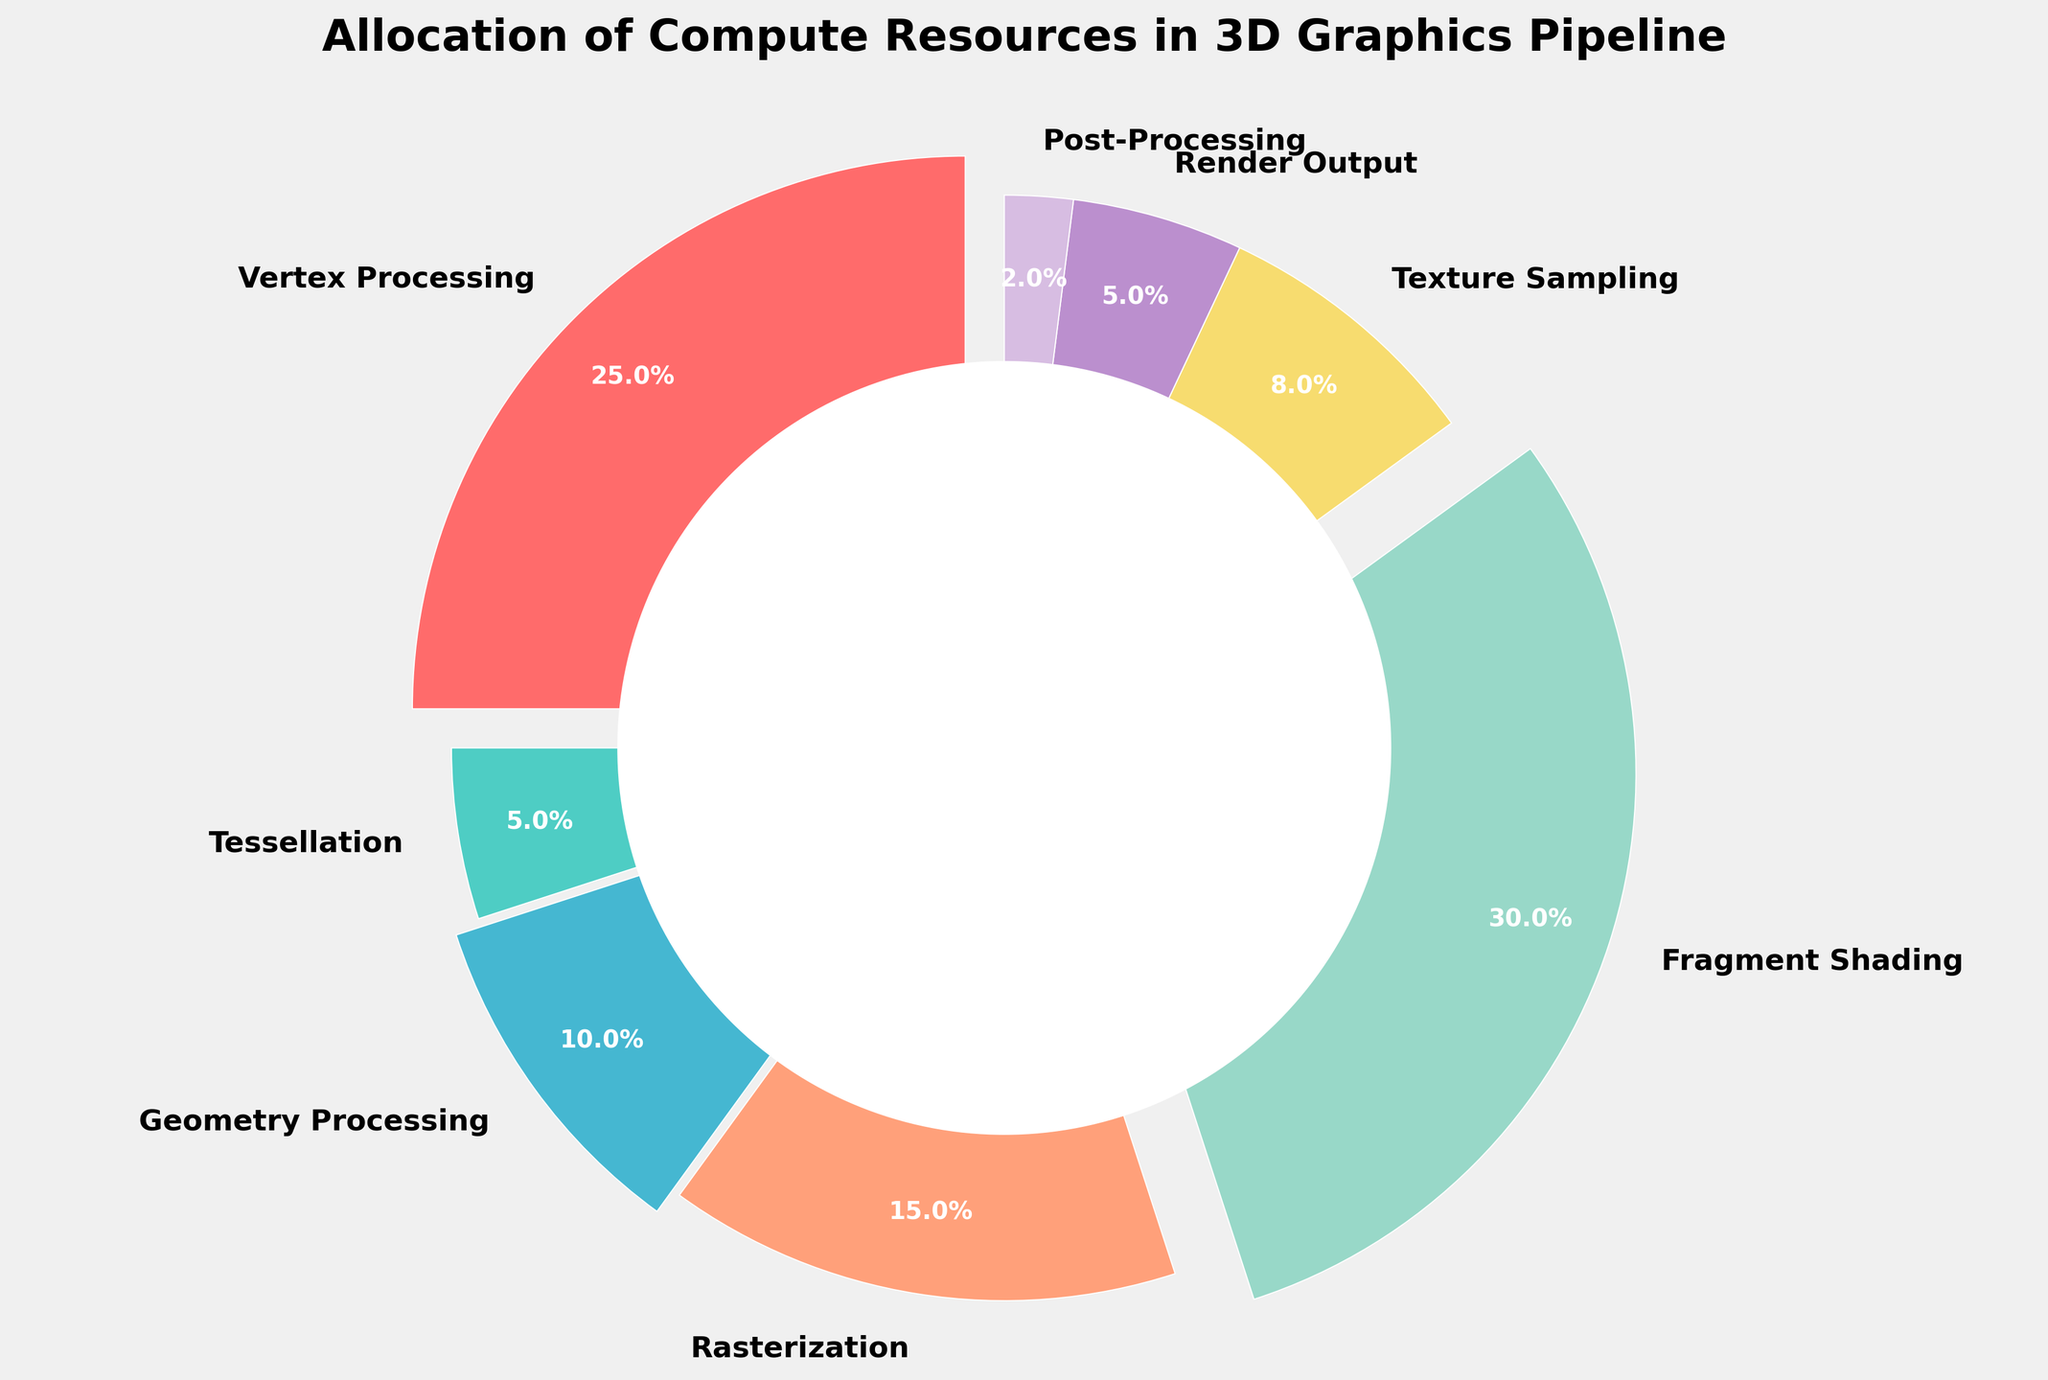What stage has the highest allocation of compute resources? By looking at the pie chart, the largest slice can be identified by its size and the percentage label. Fragment Shading has the highest allocation with 30%.
Answer: Fragment Shading Which two stages together contribute the smallest percentage of compute resources? Summing the smallest percentages labeled on the pie chart and finding the two stages that minimize this sum: Post-Processing (2%) and Render Output (5%) together contribute 7%.
Answer: Post-Processing and Render Output How much more is the compute resource allocation for Fragment Shading compared to Geometry Processing? Directly comparing the percentages labeled on the pie chart, Fragment Shading is 30% and Geometry Processing is 10%. The difference is 30% - 10% = 20%.
Answer: 20% What is the total percentage allocated to Vertex Processing, Rasterization, and Fragment Shading combined? Adding the percentages found on the pie chart: Vertex Processing (25%), Rasterization (15%), and Fragment Shading (30%) gives 25% + 15% + 30% = 70%.
Answer: 70% Which stages are represented by colors red and peach, respectively? Identifying the colors from the pie chart legend or visual representation: Vertex Processing is red and Rasterization is peach.
Answer: Vertex Processing and Rasterization How does the percentage of Tessellation compare to Texture Sampling? Comparing the percentages from the pie chart: Tessellation is 5% and Texture Sampling is 8%. Tessellation (5%) < Texture Sampling (8%).
Answer: Tessellation is less than Texture Sampling If the total allocation needed for rendering is 100%, how much percentage remains if we exclude Fragment Shading and Rasterization? Subtracting the percentage of Fragment Shading (30%) and Rasterization (15%) from 100%: 100% - 30% - 15% = 55%.
Answer: 55% What is the average percentage allocation for all stages? Calculating the average by adding all percentages and dividing by the number of stages: (25% + 5% + 10% + 15% + 30% + 8% + 5% + 2%) / 8 stages = 12.5%.
Answer: 12.5% Which stage has a compute resource allocation exactly twice that of Render Output? Comparing percentages to find the stage that is exactly twice Render Output (5%). Tessellation (5%) x 2 = Vertex Processing (10%). Answer is incorrect, Geometry Processing (10%) is correct.
Answer: Geometry Processing 